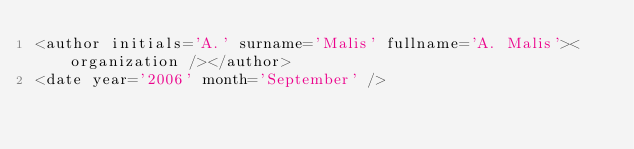<code> <loc_0><loc_0><loc_500><loc_500><_XML_><author initials='A.' surname='Malis' fullname='A. Malis'><organization /></author>
<date year='2006' month='September' /></code> 